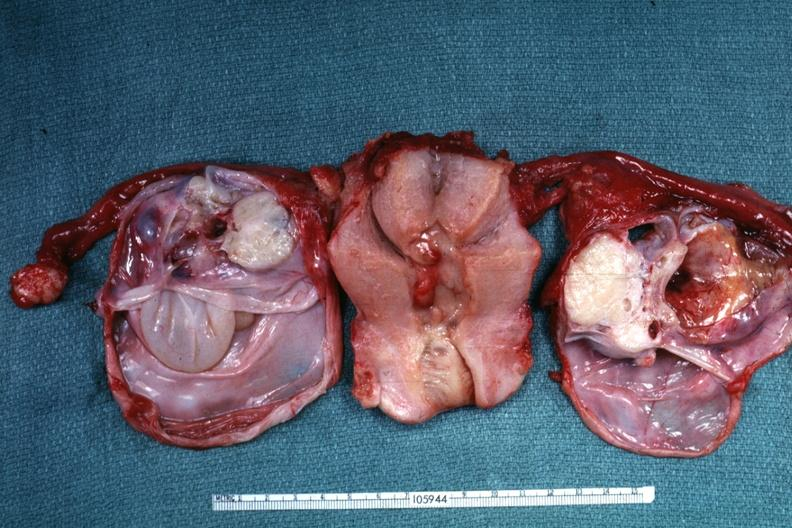what is present?
Answer the question using a single word or phrase. Serous cystadenoma 